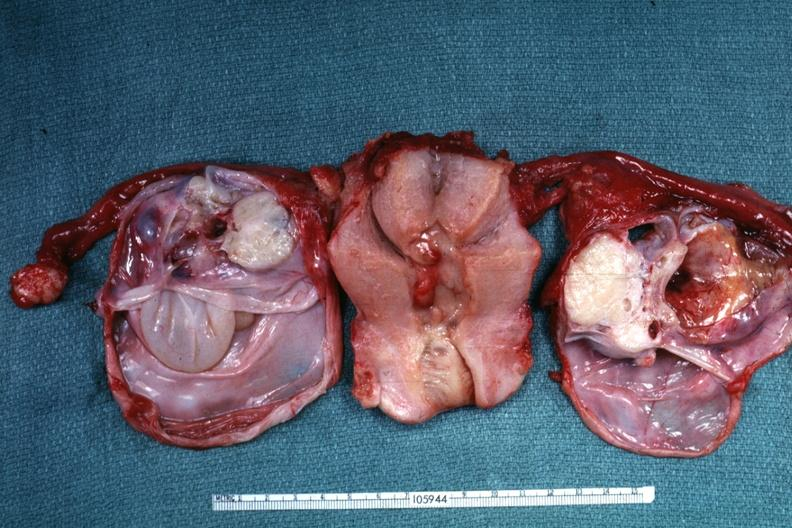what is present?
Answer the question using a single word or phrase. Serous cystadenoma 